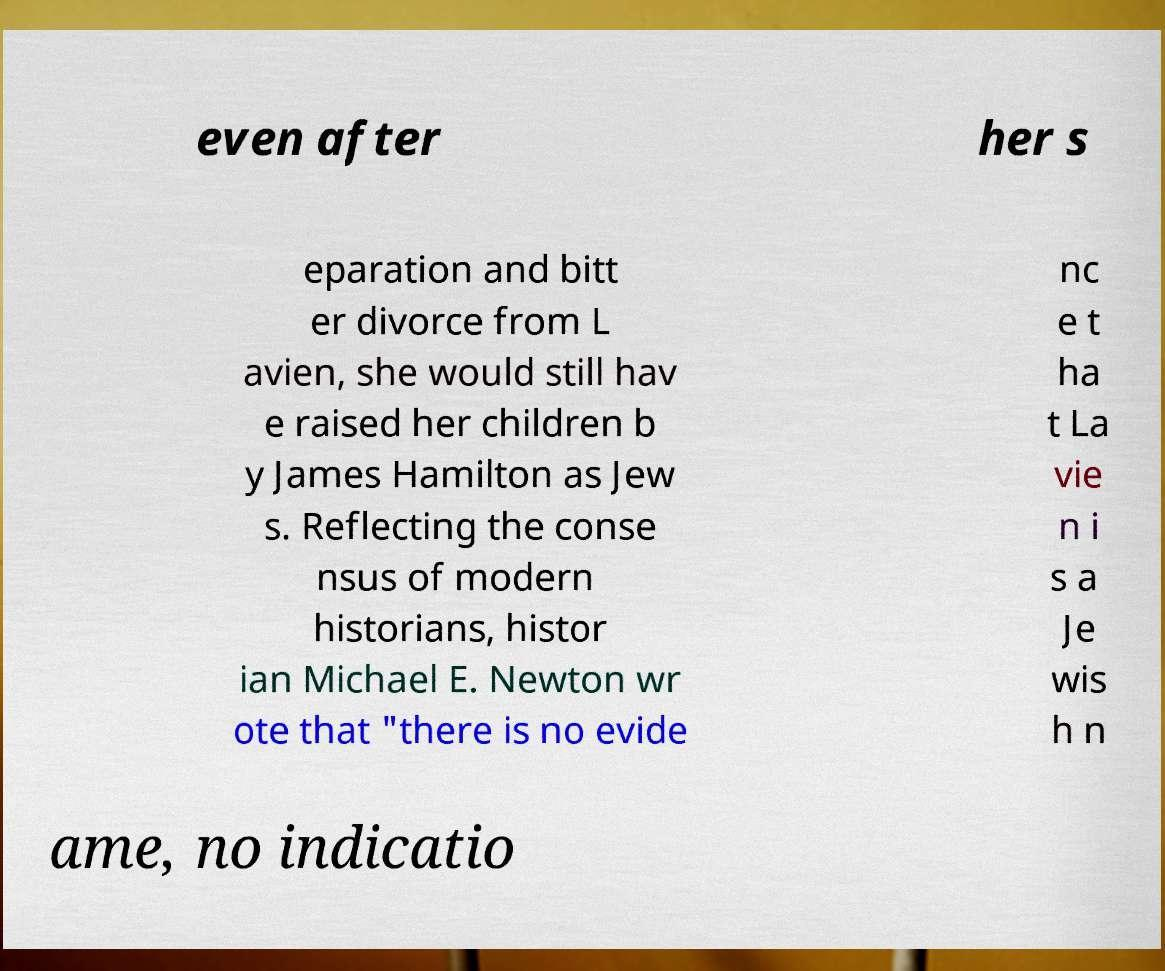Can you accurately transcribe the text from the provided image for me? even after her s eparation and bitt er divorce from L avien, she would still hav e raised her children b y James Hamilton as Jew s. Reflecting the conse nsus of modern historians, histor ian Michael E. Newton wr ote that "there is no evide nc e t ha t La vie n i s a Je wis h n ame, no indicatio 